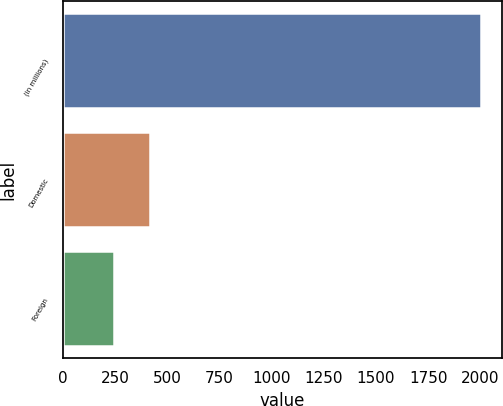Convert chart. <chart><loc_0><loc_0><loc_500><loc_500><bar_chart><fcel>(in millions)<fcel>Domestic<fcel>Foreign<nl><fcel>2002<fcel>419.8<fcel>244<nl></chart> 